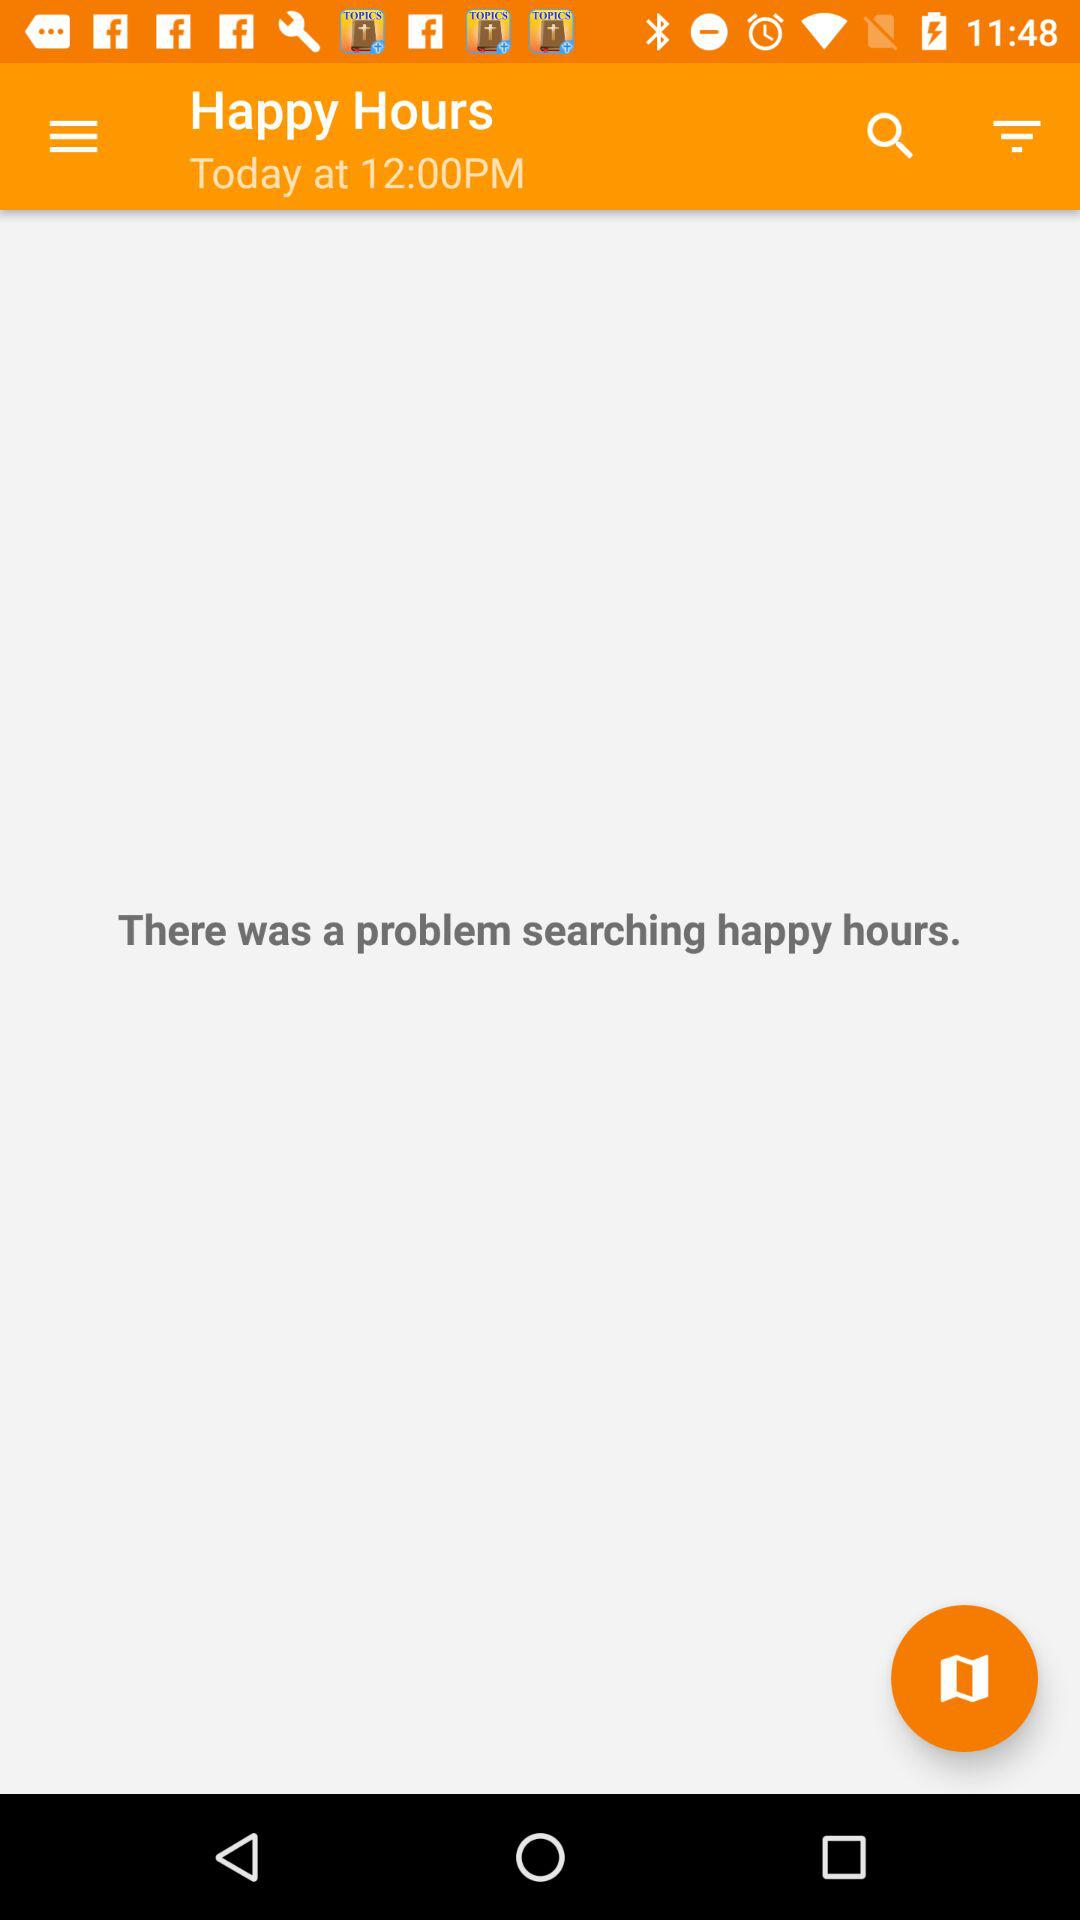What is the time shown on the screen? The time shown on the screen is 12:00 PM. 